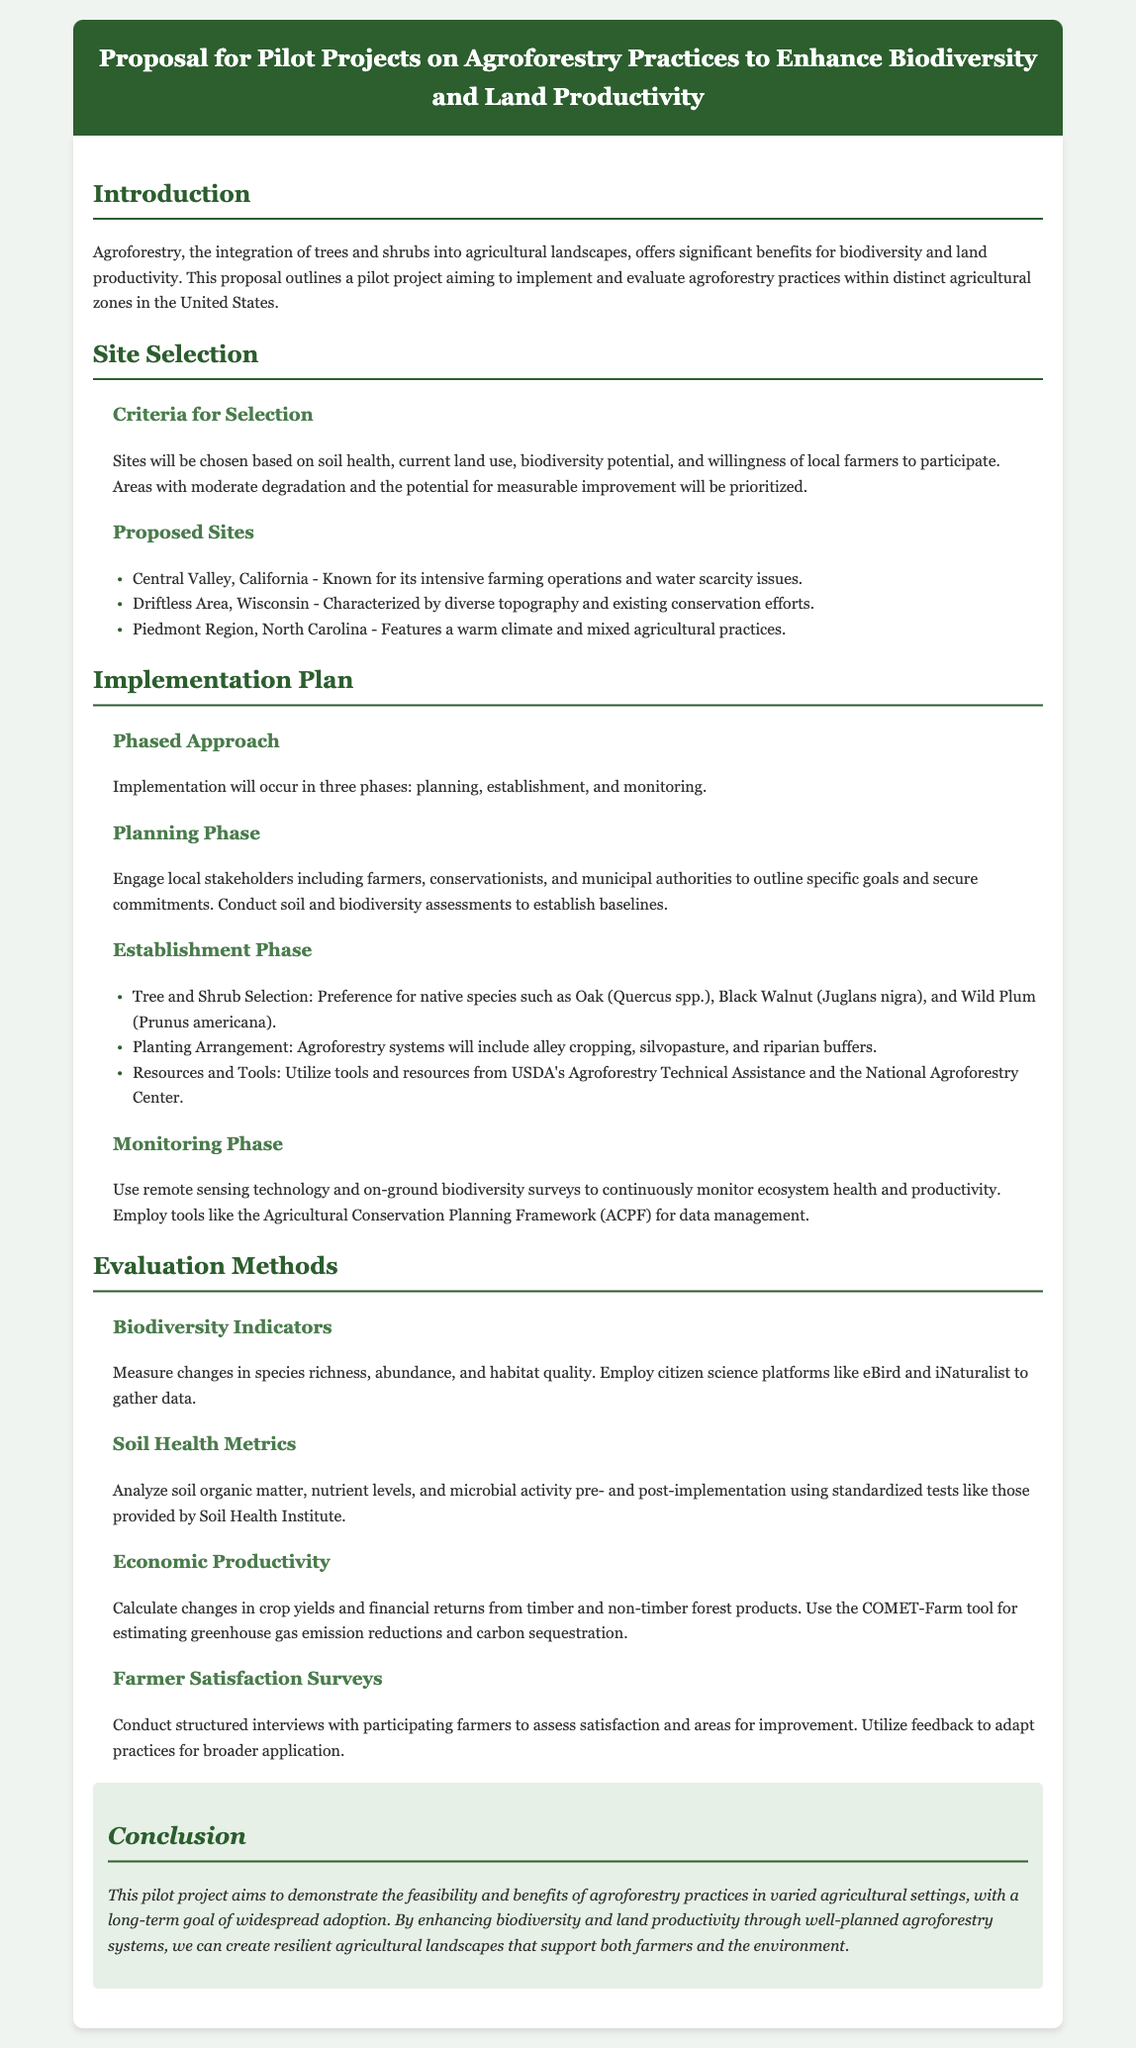What is the main focus of the proposal? The proposal primarily focuses on implementing and evaluating agroforestry practices within distinct agricultural zones in the United States.
Answer: Agroforestry practices What are the criteria for site selection? The document outlines specific criteria for selecting sites, including factors like soil health and farmer willingness.
Answer: Soil health, current land use, biodiversity potential, farmer willingness Which region is mentioned for its intensive farming operations? The proposal specifies a region that is known for its intensive farming and water scarcity issues.
Answer: Central Valley, California How many phases are there in the implementation plan? The document states the implementation will occur in phases, specifically detailing them within the plan.
Answer: Three phases What method will be used to monitor biodiversity? The proposal mentions a specific approach for continuous monitoring of ecosystem health and productivity in terms of biodiversity.
Answer: Remote sensing technology and on-ground biodiversity surveys What are some selected tree species for the establishment phase? The document lists preferred native species that will be selected during the establishment phase.
Answer: Oak, Black Walnut, Wild Plum What tool is suggested for calculation of economic productivity? The proposal recommends a specific tool for estimating financial outcomes related to agricultural productivity.
Answer: COMET-Farm What types of surveys will be conducted for farmer feedback? The document discusses a method of collecting feedback from participating farmers regarding their experiences.
Answer: Structured interviews 